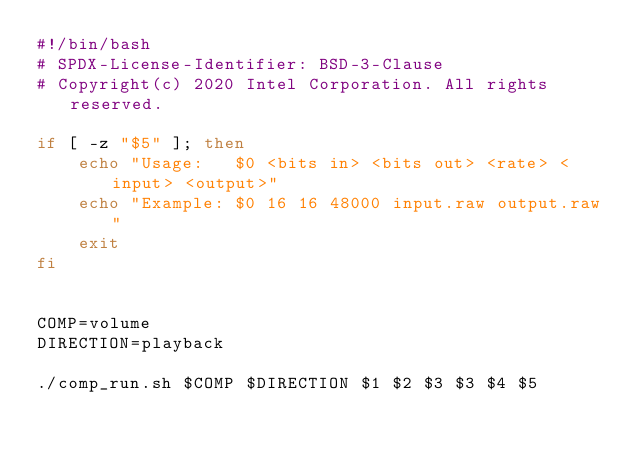Convert code to text. <code><loc_0><loc_0><loc_500><loc_500><_Bash_>#!/bin/bash
# SPDX-License-Identifier: BSD-3-Clause
# Copyright(c) 2020 Intel Corporation. All rights reserved.

if [ -z "$5" ]; then
    echo "Usage:   $0 <bits in> <bits out> <rate> <input> <output>"
    echo "Example: $0 16 16 48000 input.raw output.raw"
    exit
fi


COMP=volume
DIRECTION=playback

./comp_run.sh $COMP $DIRECTION $1 $2 $3 $3 $4 $5
</code> 